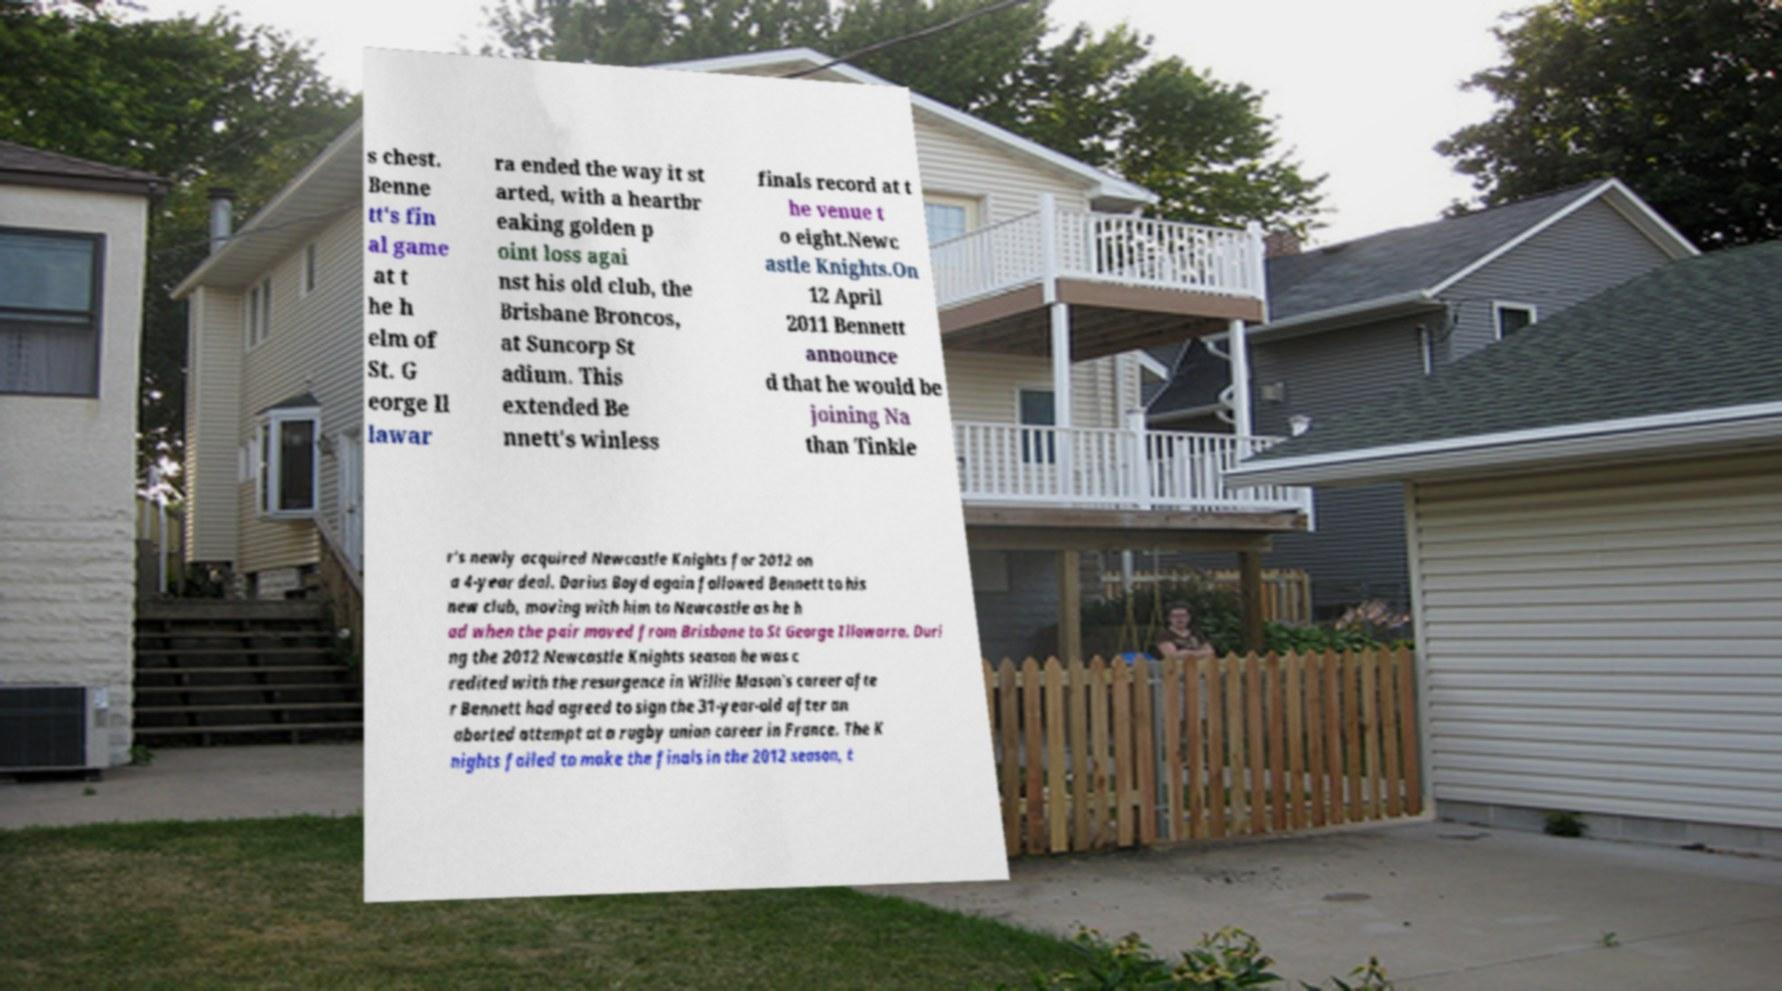I need the written content from this picture converted into text. Can you do that? s chest. Benne tt's fin al game at t he h elm of St. G eorge Il lawar ra ended the way it st arted, with a heartbr eaking golden p oint loss agai nst his old club, the Brisbane Broncos, at Suncorp St adium. This extended Be nnett's winless finals record at t he venue t o eight.Newc astle Knights.On 12 April 2011 Bennett announce d that he would be joining Na than Tinkle r's newly acquired Newcastle Knights for 2012 on a 4-year deal. Darius Boyd again followed Bennett to his new club, moving with him to Newcastle as he h ad when the pair moved from Brisbane to St George Illawarra. Duri ng the 2012 Newcastle Knights season he was c redited with the resurgence in Willie Mason's career afte r Bennett had agreed to sign the 31-year-old after an aborted attempt at a rugby union career in France. The K nights failed to make the finals in the 2012 season, t 